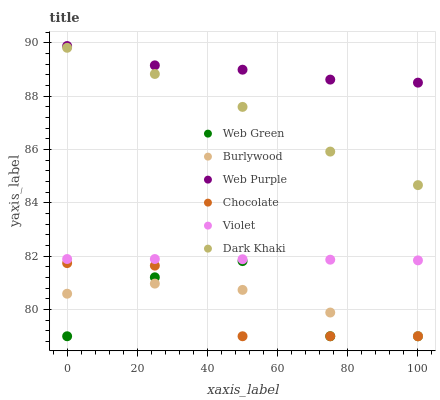Does Chocolate have the minimum area under the curve?
Answer yes or no. Yes. Does Web Purple have the maximum area under the curve?
Answer yes or no. Yes. Does Web Green have the minimum area under the curve?
Answer yes or no. No. Does Web Green have the maximum area under the curve?
Answer yes or no. No. Is Violet the smoothest?
Answer yes or no. Yes. Is Web Green the roughest?
Answer yes or no. Yes. Is Chocolate the smoothest?
Answer yes or no. No. Is Chocolate the roughest?
Answer yes or no. No. Does Burlywood have the lowest value?
Answer yes or no. Yes. Does Dark Khaki have the lowest value?
Answer yes or no. No. Does Web Purple have the highest value?
Answer yes or no. Yes. Does Web Green have the highest value?
Answer yes or no. No. Is Web Green less than Dark Khaki?
Answer yes or no. Yes. Is Dark Khaki greater than Web Green?
Answer yes or no. Yes. Does Chocolate intersect Web Green?
Answer yes or no. Yes. Is Chocolate less than Web Green?
Answer yes or no. No. Is Chocolate greater than Web Green?
Answer yes or no. No. Does Web Green intersect Dark Khaki?
Answer yes or no. No. 